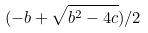Convert formula to latex. <formula><loc_0><loc_0><loc_500><loc_500>( - b + \sqrt { b ^ { 2 } - 4 c } ) / 2</formula> 